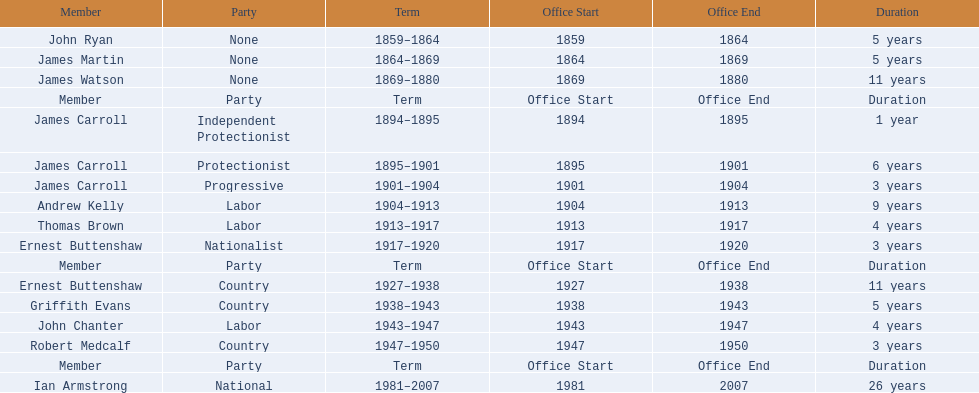Which member of the second incarnation of the lachlan was also a nationalist? Ernest Buttenshaw. 